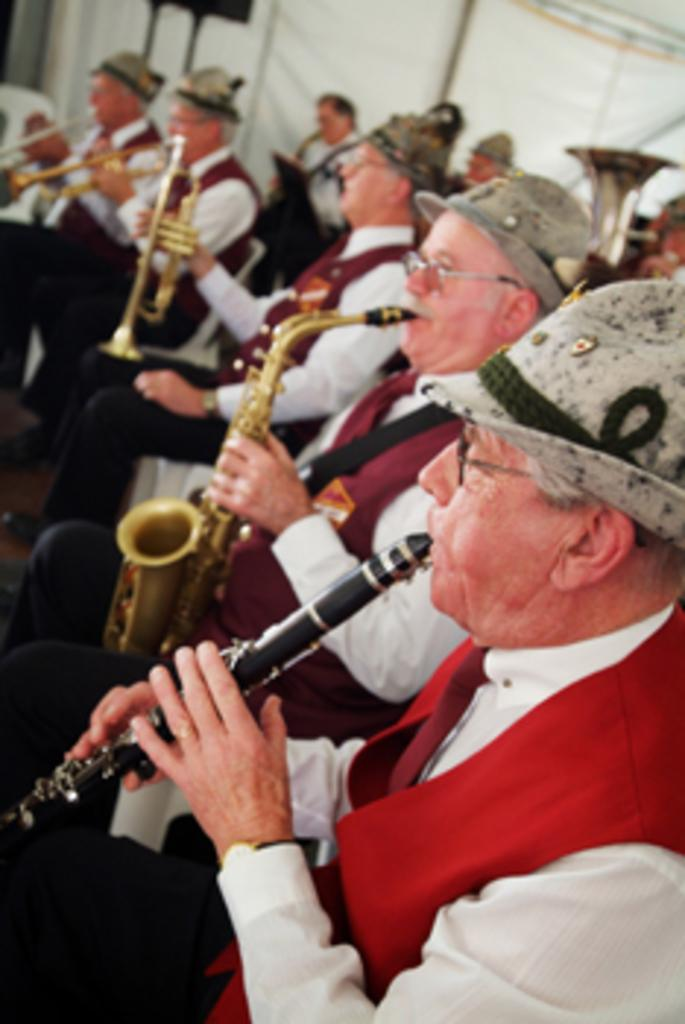How many people are in the image? There are persons in the image. What are the persons wearing on their heads? The persons are wearing hats. What are the persons doing in the image? The persons are playing musical instruments. Can you tell me who won the argument between the father and the person playing the guitar in the image? There is no father or argument present in the image; it features persons playing musical instruments while wearing hats. 